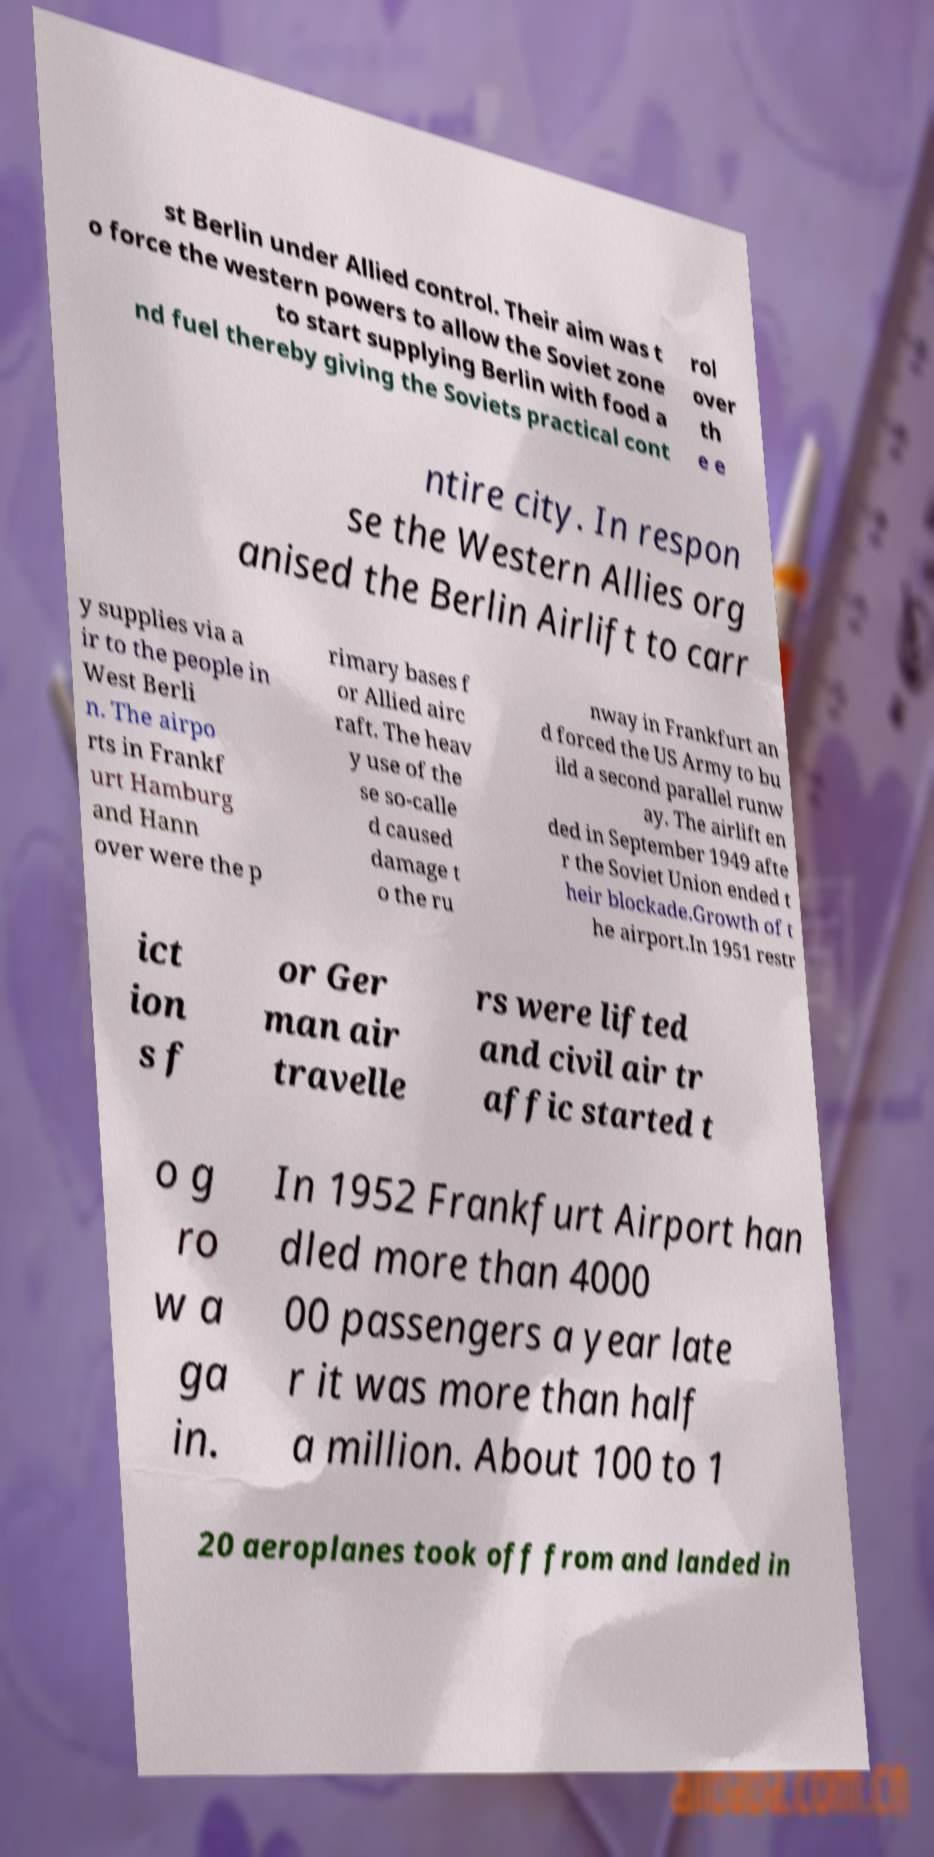Could you assist in decoding the text presented in this image and type it out clearly? st Berlin under Allied control. Their aim was t o force the western powers to allow the Soviet zone to start supplying Berlin with food a nd fuel thereby giving the Soviets practical cont rol over th e e ntire city. In respon se the Western Allies org anised the Berlin Airlift to carr y supplies via a ir to the people in West Berli n. The airpo rts in Frankf urt Hamburg and Hann over were the p rimary bases f or Allied airc raft. The heav y use of the se so-calle d caused damage t o the ru nway in Frankfurt an d forced the US Army to bu ild a second parallel runw ay. The airlift en ded in September 1949 afte r the Soviet Union ended t heir blockade.Growth of t he airport.In 1951 restr ict ion s f or Ger man air travelle rs were lifted and civil air tr affic started t o g ro w a ga in. In 1952 Frankfurt Airport han dled more than 4000 00 passengers a year late r it was more than half a million. About 100 to 1 20 aeroplanes took off from and landed in 